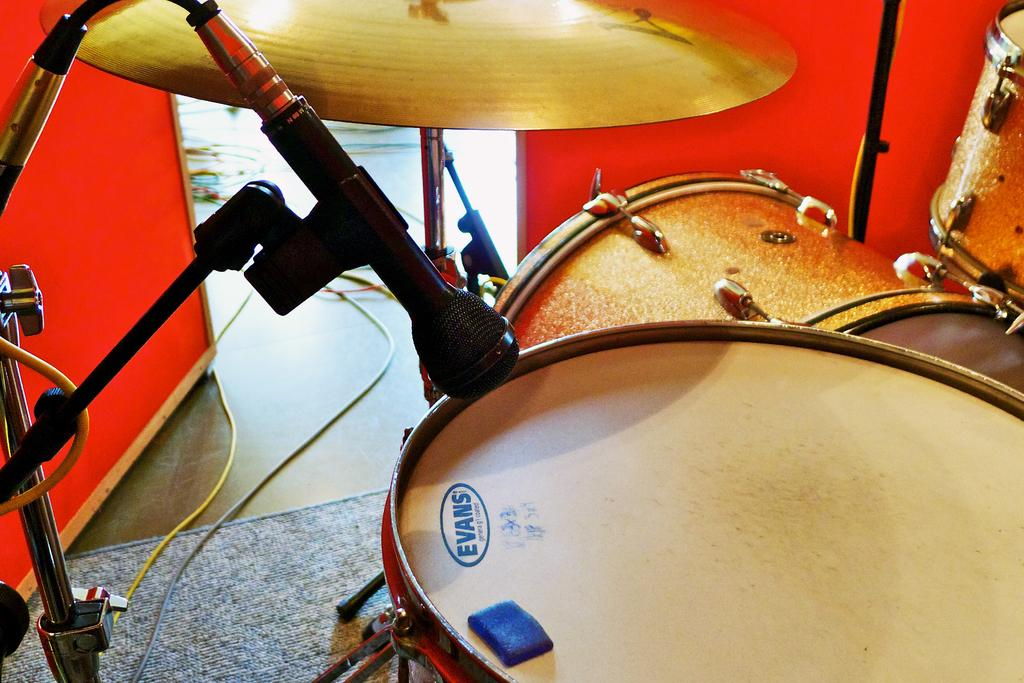What musical instruments are present in the image? There are drums in the image. Where is the microphone located in the image? The microphone is on the left side of the image. What can be seen on the floor in the background of the image? There are cables on the floor in the background of the image. What color is the wall visible in the background of the image? There is a red wall in the background of the image. What type of kite is being used as a reason in the image? There is no kite present in the image, nor is there any reference to a reason. 